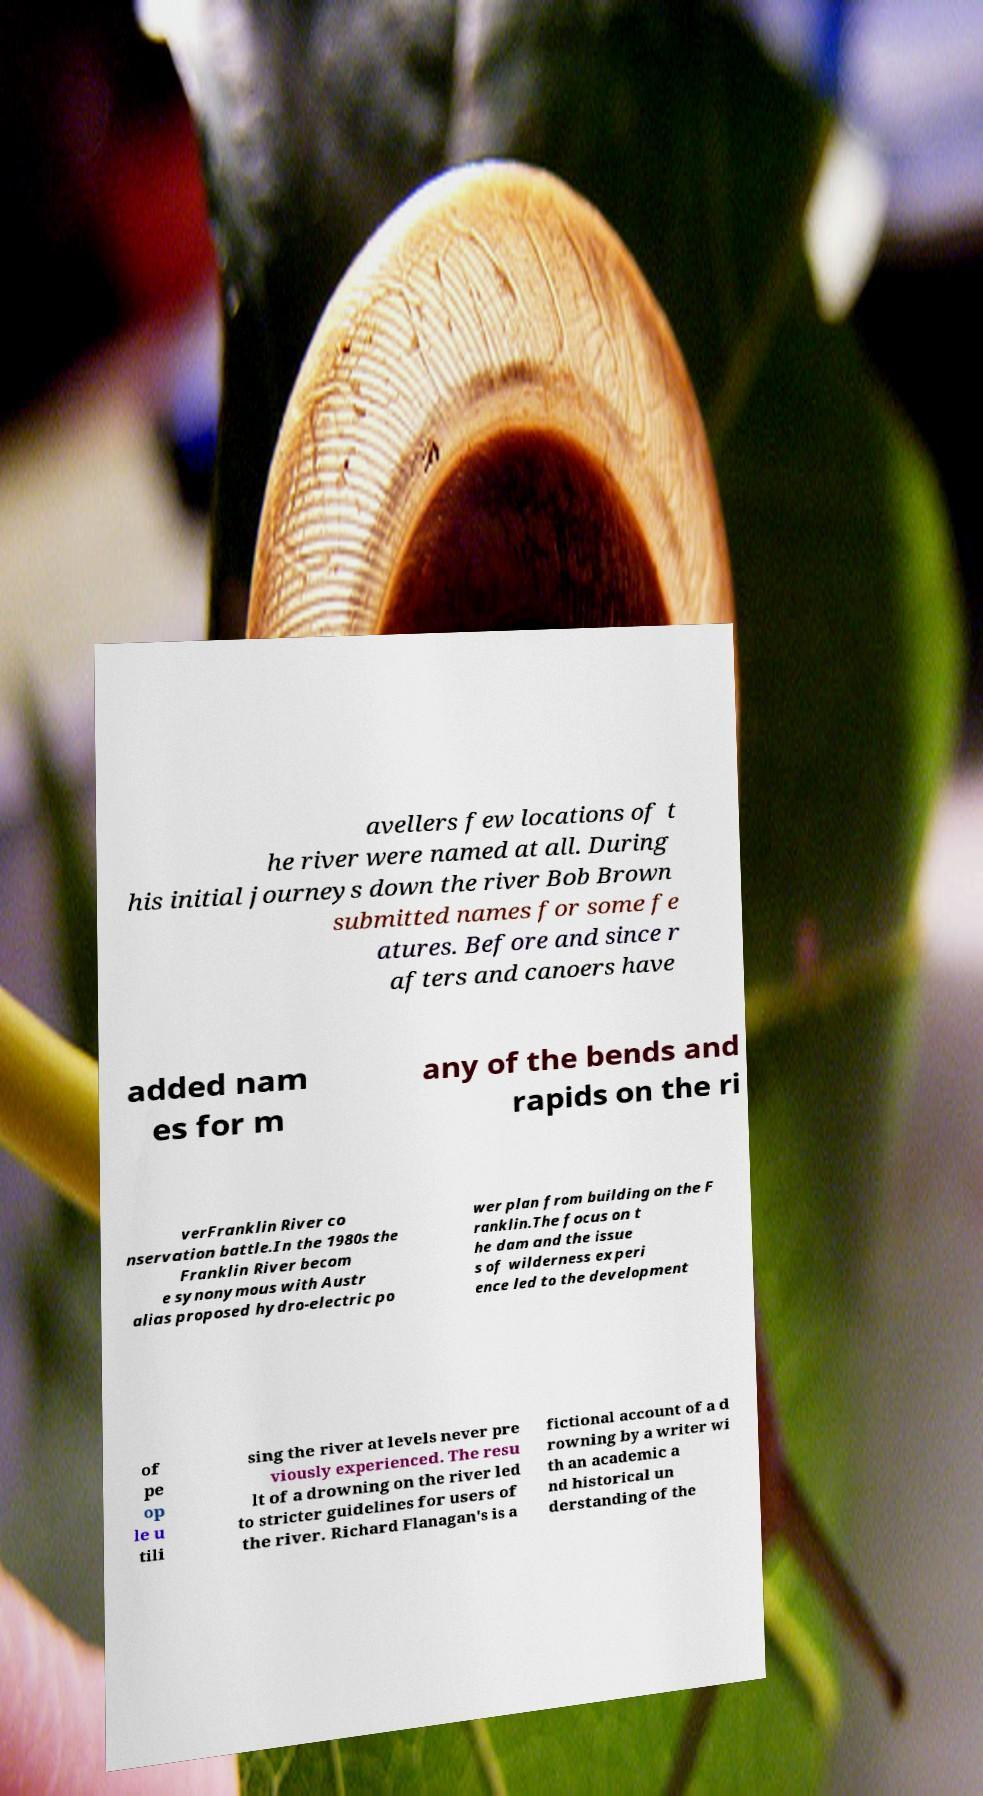What messages or text are displayed in this image? I need them in a readable, typed format. avellers few locations of t he river were named at all. During his initial journeys down the river Bob Brown submitted names for some fe atures. Before and since r afters and canoers have added nam es for m any of the bends and rapids on the ri verFranklin River co nservation battle.In the 1980s the Franklin River becom e synonymous with Austr alias proposed hydro-electric po wer plan from building on the F ranklin.The focus on t he dam and the issue s of wilderness experi ence led to the development of pe op le u tili sing the river at levels never pre viously experienced. The resu lt of a drowning on the river led to stricter guidelines for users of the river. Richard Flanagan's is a fictional account of a d rowning by a writer wi th an academic a nd historical un derstanding of the 